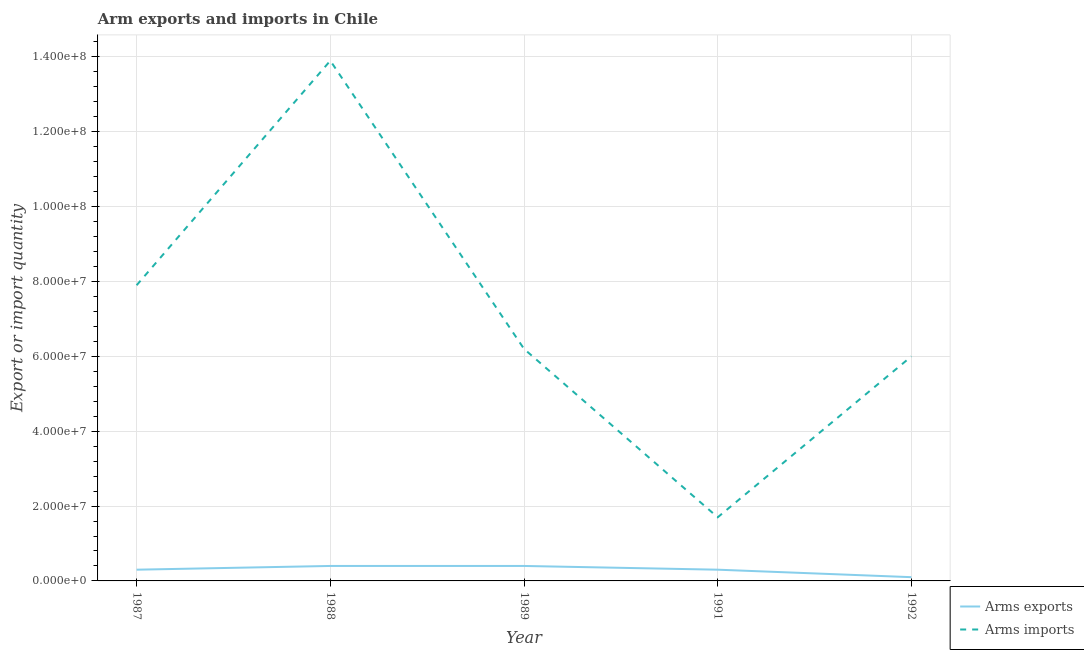Does the line corresponding to arms exports intersect with the line corresponding to arms imports?
Give a very brief answer. No. What is the arms imports in 1991?
Make the answer very short. 1.70e+07. Across all years, what is the maximum arms exports?
Ensure brevity in your answer.  4.00e+06. Across all years, what is the minimum arms imports?
Offer a very short reply. 1.70e+07. In which year was the arms imports maximum?
Provide a short and direct response. 1988. What is the total arms imports in the graph?
Give a very brief answer. 3.57e+08. What is the difference between the arms imports in 1988 and that in 1989?
Ensure brevity in your answer.  7.70e+07. What is the difference between the arms exports in 1991 and the arms imports in 1992?
Make the answer very short. -5.70e+07. What is the average arms imports per year?
Give a very brief answer. 7.14e+07. In the year 1987, what is the difference between the arms exports and arms imports?
Ensure brevity in your answer.  -7.60e+07. In how many years, is the arms imports greater than 112000000?
Give a very brief answer. 1. What is the ratio of the arms imports in 1987 to that in 1989?
Keep it short and to the point. 1.27. Is the difference between the arms exports in 1987 and 1988 greater than the difference between the arms imports in 1987 and 1988?
Give a very brief answer. Yes. What is the difference between the highest and the second highest arms exports?
Provide a short and direct response. 0. What is the difference between the highest and the lowest arms exports?
Provide a succinct answer. 3.00e+06. In how many years, is the arms imports greater than the average arms imports taken over all years?
Ensure brevity in your answer.  2. Does the arms exports monotonically increase over the years?
Provide a succinct answer. No. How many lines are there?
Make the answer very short. 2. Does the graph contain grids?
Provide a short and direct response. Yes. How many legend labels are there?
Keep it short and to the point. 2. How are the legend labels stacked?
Offer a terse response. Vertical. What is the title of the graph?
Your answer should be very brief. Arm exports and imports in Chile. What is the label or title of the X-axis?
Your response must be concise. Year. What is the label or title of the Y-axis?
Offer a very short reply. Export or import quantity. What is the Export or import quantity in Arms imports in 1987?
Your answer should be compact. 7.90e+07. What is the Export or import quantity of Arms exports in 1988?
Provide a succinct answer. 4.00e+06. What is the Export or import quantity of Arms imports in 1988?
Offer a very short reply. 1.39e+08. What is the Export or import quantity in Arms imports in 1989?
Offer a terse response. 6.20e+07. What is the Export or import quantity in Arms imports in 1991?
Your answer should be compact. 1.70e+07. What is the Export or import quantity of Arms imports in 1992?
Offer a very short reply. 6.00e+07. Across all years, what is the maximum Export or import quantity in Arms exports?
Make the answer very short. 4.00e+06. Across all years, what is the maximum Export or import quantity in Arms imports?
Your answer should be very brief. 1.39e+08. Across all years, what is the minimum Export or import quantity of Arms exports?
Your answer should be compact. 1.00e+06. Across all years, what is the minimum Export or import quantity in Arms imports?
Your answer should be very brief. 1.70e+07. What is the total Export or import quantity of Arms exports in the graph?
Give a very brief answer. 1.50e+07. What is the total Export or import quantity of Arms imports in the graph?
Your response must be concise. 3.57e+08. What is the difference between the Export or import quantity of Arms exports in 1987 and that in 1988?
Your response must be concise. -1.00e+06. What is the difference between the Export or import quantity in Arms imports in 1987 and that in 1988?
Your answer should be very brief. -6.00e+07. What is the difference between the Export or import quantity in Arms imports in 1987 and that in 1989?
Provide a succinct answer. 1.70e+07. What is the difference between the Export or import quantity of Arms imports in 1987 and that in 1991?
Provide a short and direct response. 6.20e+07. What is the difference between the Export or import quantity of Arms exports in 1987 and that in 1992?
Provide a succinct answer. 2.00e+06. What is the difference between the Export or import quantity in Arms imports in 1987 and that in 1992?
Ensure brevity in your answer.  1.90e+07. What is the difference between the Export or import quantity of Arms exports in 1988 and that in 1989?
Your response must be concise. 0. What is the difference between the Export or import quantity of Arms imports in 1988 and that in 1989?
Keep it short and to the point. 7.70e+07. What is the difference between the Export or import quantity in Arms exports in 1988 and that in 1991?
Give a very brief answer. 1.00e+06. What is the difference between the Export or import quantity in Arms imports in 1988 and that in 1991?
Your answer should be very brief. 1.22e+08. What is the difference between the Export or import quantity in Arms imports in 1988 and that in 1992?
Ensure brevity in your answer.  7.90e+07. What is the difference between the Export or import quantity of Arms imports in 1989 and that in 1991?
Give a very brief answer. 4.50e+07. What is the difference between the Export or import quantity of Arms imports in 1989 and that in 1992?
Give a very brief answer. 2.00e+06. What is the difference between the Export or import quantity in Arms imports in 1991 and that in 1992?
Your answer should be compact. -4.30e+07. What is the difference between the Export or import quantity in Arms exports in 1987 and the Export or import quantity in Arms imports in 1988?
Give a very brief answer. -1.36e+08. What is the difference between the Export or import quantity in Arms exports in 1987 and the Export or import quantity in Arms imports in 1989?
Offer a terse response. -5.90e+07. What is the difference between the Export or import quantity in Arms exports in 1987 and the Export or import quantity in Arms imports in 1991?
Offer a very short reply. -1.40e+07. What is the difference between the Export or import quantity in Arms exports in 1987 and the Export or import quantity in Arms imports in 1992?
Offer a very short reply. -5.70e+07. What is the difference between the Export or import quantity of Arms exports in 1988 and the Export or import quantity of Arms imports in 1989?
Your answer should be compact. -5.80e+07. What is the difference between the Export or import quantity in Arms exports in 1988 and the Export or import quantity in Arms imports in 1991?
Provide a short and direct response. -1.30e+07. What is the difference between the Export or import quantity in Arms exports in 1988 and the Export or import quantity in Arms imports in 1992?
Offer a terse response. -5.60e+07. What is the difference between the Export or import quantity of Arms exports in 1989 and the Export or import quantity of Arms imports in 1991?
Make the answer very short. -1.30e+07. What is the difference between the Export or import quantity in Arms exports in 1989 and the Export or import quantity in Arms imports in 1992?
Keep it short and to the point. -5.60e+07. What is the difference between the Export or import quantity of Arms exports in 1991 and the Export or import quantity of Arms imports in 1992?
Offer a very short reply. -5.70e+07. What is the average Export or import quantity in Arms imports per year?
Offer a very short reply. 7.14e+07. In the year 1987, what is the difference between the Export or import quantity of Arms exports and Export or import quantity of Arms imports?
Offer a terse response. -7.60e+07. In the year 1988, what is the difference between the Export or import quantity of Arms exports and Export or import quantity of Arms imports?
Provide a short and direct response. -1.35e+08. In the year 1989, what is the difference between the Export or import quantity in Arms exports and Export or import quantity in Arms imports?
Offer a terse response. -5.80e+07. In the year 1991, what is the difference between the Export or import quantity in Arms exports and Export or import quantity in Arms imports?
Provide a succinct answer. -1.40e+07. In the year 1992, what is the difference between the Export or import quantity in Arms exports and Export or import quantity in Arms imports?
Your answer should be compact. -5.90e+07. What is the ratio of the Export or import quantity of Arms exports in 1987 to that in 1988?
Ensure brevity in your answer.  0.75. What is the ratio of the Export or import quantity in Arms imports in 1987 to that in 1988?
Offer a very short reply. 0.57. What is the ratio of the Export or import quantity of Arms exports in 1987 to that in 1989?
Offer a very short reply. 0.75. What is the ratio of the Export or import quantity of Arms imports in 1987 to that in 1989?
Offer a very short reply. 1.27. What is the ratio of the Export or import quantity of Arms imports in 1987 to that in 1991?
Provide a short and direct response. 4.65. What is the ratio of the Export or import quantity in Arms exports in 1987 to that in 1992?
Your answer should be very brief. 3. What is the ratio of the Export or import quantity of Arms imports in 1987 to that in 1992?
Make the answer very short. 1.32. What is the ratio of the Export or import quantity of Arms exports in 1988 to that in 1989?
Make the answer very short. 1. What is the ratio of the Export or import quantity of Arms imports in 1988 to that in 1989?
Offer a terse response. 2.24. What is the ratio of the Export or import quantity of Arms imports in 1988 to that in 1991?
Offer a very short reply. 8.18. What is the ratio of the Export or import quantity in Arms imports in 1988 to that in 1992?
Provide a short and direct response. 2.32. What is the ratio of the Export or import quantity in Arms exports in 1989 to that in 1991?
Offer a very short reply. 1.33. What is the ratio of the Export or import quantity in Arms imports in 1989 to that in 1991?
Keep it short and to the point. 3.65. What is the ratio of the Export or import quantity of Arms imports in 1989 to that in 1992?
Give a very brief answer. 1.03. What is the ratio of the Export or import quantity of Arms imports in 1991 to that in 1992?
Offer a very short reply. 0.28. What is the difference between the highest and the second highest Export or import quantity of Arms exports?
Your answer should be compact. 0. What is the difference between the highest and the second highest Export or import quantity of Arms imports?
Provide a succinct answer. 6.00e+07. What is the difference between the highest and the lowest Export or import quantity in Arms imports?
Give a very brief answer. 1.22e+08. 